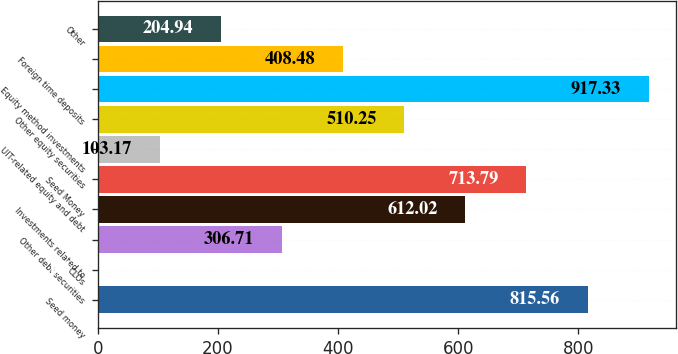Convert chart. <chart><loc_0><loc_0><loc_500><loc_500><bar_chart><fcel>Seed money<fcel>CLOs<fcel>Other debt securities<fcel>Investments related to<fcel>Seed Money<fcel>UIT-related equity and debt<fcel>Other equity securities<fcel>Equity method investments<fcel>Foreign time deposits<fcel>Other<nl><fcel>815.56<fcel>1.4<fcel>306.71<fcel>612.02<fcel>713.79<fcel>103.17<fcel>510.25<fcel>917.33<fcel>408.48<fcel>204.94<nl></chart> 